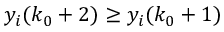<formula> <loc_0><loc_0><loc_500><loc_500>y _ { i } ( k _ { 0 } + 2 ) \geq y _ { i } ( k _ { 0 } + 1 )</formula> 